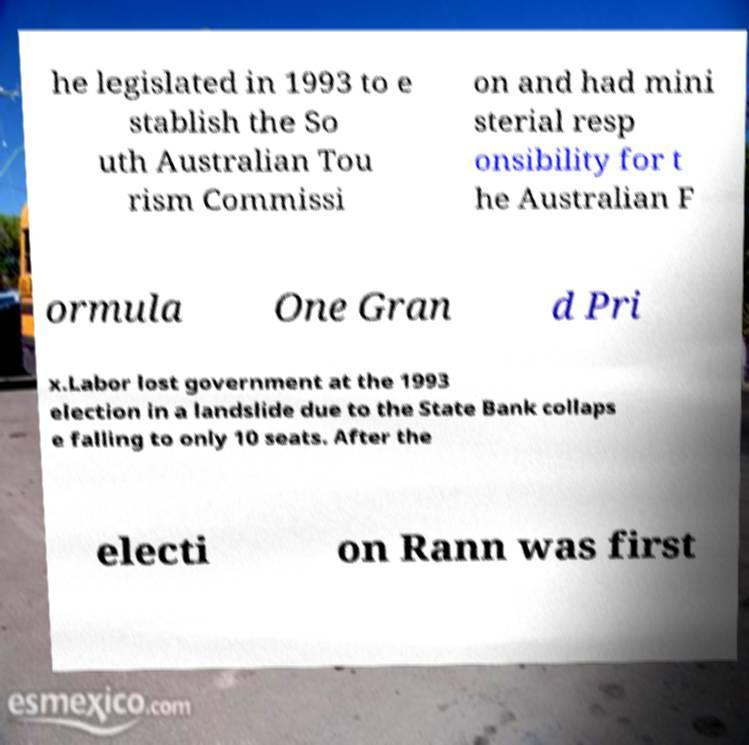Please read and relay the text visible in this image. What does it say? he legislated in 1993 to e stablish the So uth Australian Tou rism Commissi on and had mini sterial resp onsibility for t he Australian F ormula One Gran d Pri x.Labor lost government at the 1993 election in a landslide due to the State Bank collaps e falling to only 10 seats. After the electi on Rann was first 